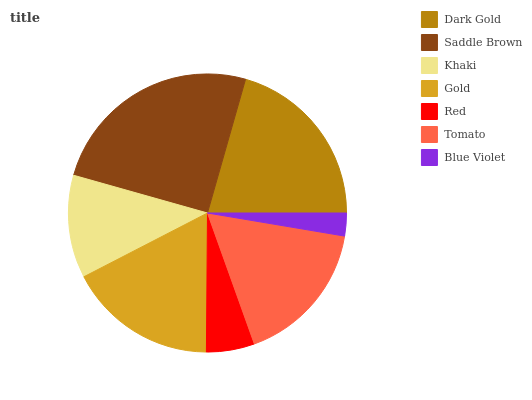Is Blue Violet the minimum?
Answer yes or no. Yes. Is Saddle Brown the maximum?
Answer yes or no. Yes. Is Khaki the minimum?
Answer yes or no. No. Is Khaki the maximum?
Answer yes or no. No. Is Saddle Brown greater than Khaki?
Answer yes or no. Yes. Is Khaki less than Saddle Brown?
Answer yes or no. Yes. Is Khaki greater than Saddle Brown?
Answer yes or no. No. Is Saddle Brown less than Khaki?
Answer yes or no. No. Is Tomato the high median?
Answer yes or no. Yes. Is Tomato the low median?
Answer yes or no. Yes. Is Blue Violet the high median?
Answer yes or no. No. Is Blue Violet the low median?
Answer yes or no. No. 